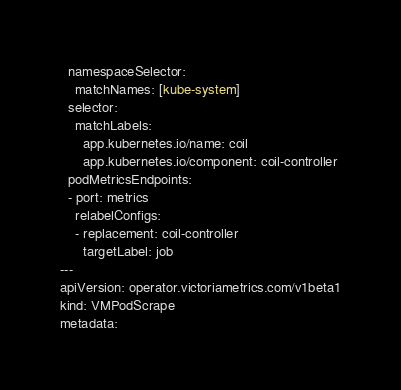<code> <loc_0><loc_0><loc_500><loc_500><_YAML_>  namespaceSelector:
    matchNames: [kube-system]
  selector:
    matchLabels:
      app.kubernetes.io/name: coil
      app.kubernetes.io/component: coil-controller
  podMetricsEndpoints:
  - port: metrics
    relabelConfigs:
    - replacement: coil-controller
      targetLabel: job
---
apiVersion: operator.victoriametrics.com/v1beta1
kind: VMPodScrape
metadata:</code> 